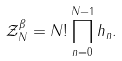Convert formula to latex. <formula><loc_0><loc_0><loc_500><loc_500>\mathcal { Z } _ { N } ^ { \beta } = N ! \prod _ { n = 0 } ^ { N - 1 } h _ { n } .</formula> 